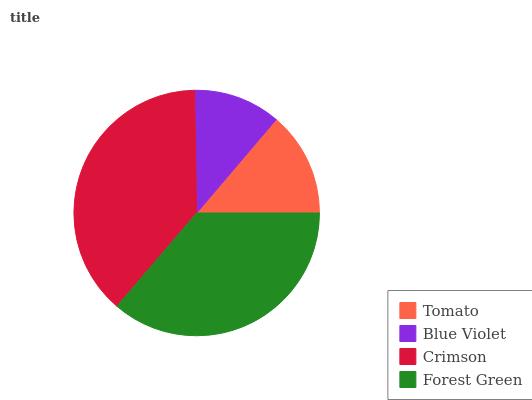Is Blue Violet the minimum?
Answer yes or no. Yes. Is Crimson the maximum?
Answer yes or no. Yes. Is Crimson the minimum?
Answer yes or no. No. Is Blue Violet the maximum?
Answer yes or no. No. Is Crimson greater than Blue Violet?
Answer yes or no. Yes. Is Blue Violet less than Crimson?
Answer yes or no. Yes. Is Blue Violet greater than Crimson?
Answer yes or no. No. Is Crimson less than Blue Violet?
Answer yes or no. No. Is Forest Green the high median?
Answer yes or no. Yes. Is Tomato the low median?
Answer yes or no. Yes. Is Crimson the high median?
Answer yes or no. No. Is Blue Violet the low median?
Answer yes or no. No. 